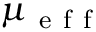Convert formula to latex. <formula><loc_0><loc_0><loc_500><loc_500>\mu _ { e f f }</formula> 